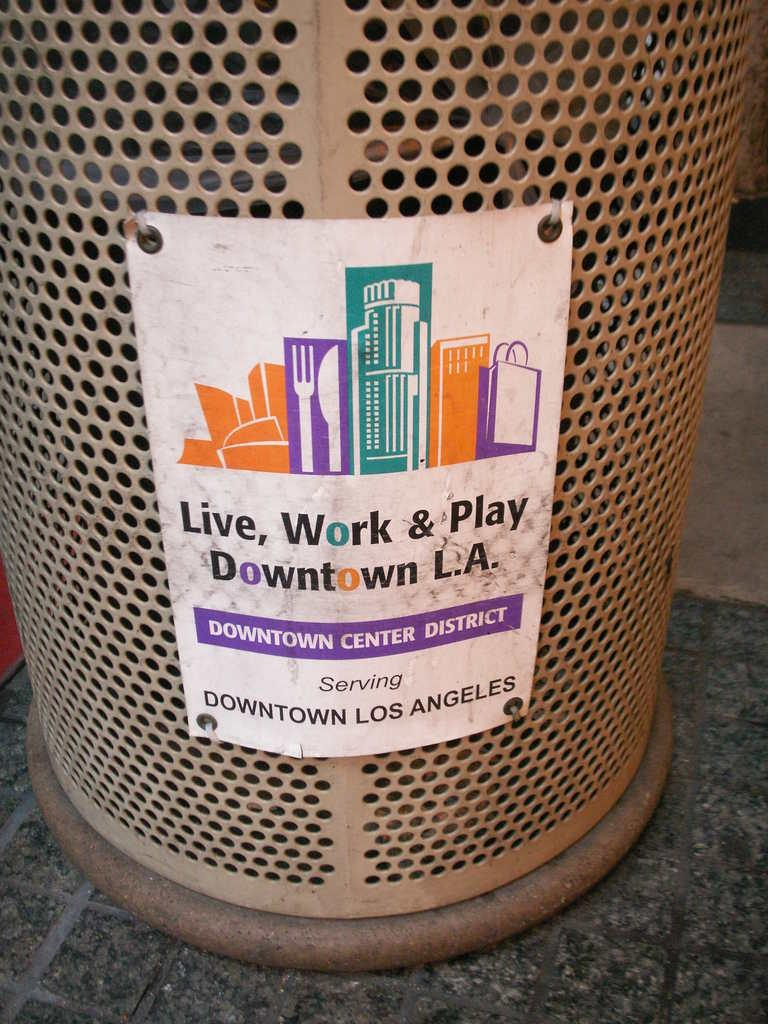Provide a one-sentence caption for the provided image. trash can in the street that reads live, work and play. 